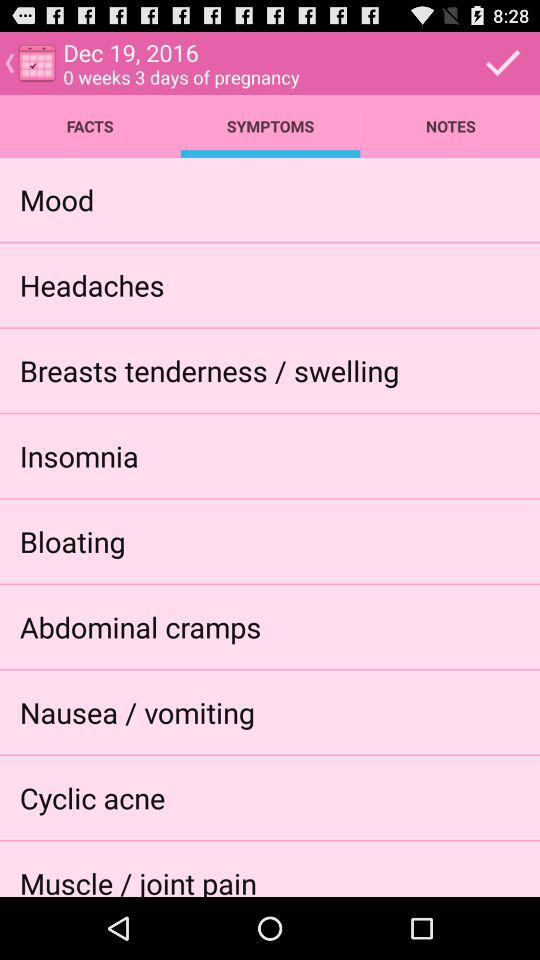What's the date? The date is December 19, 2016. 